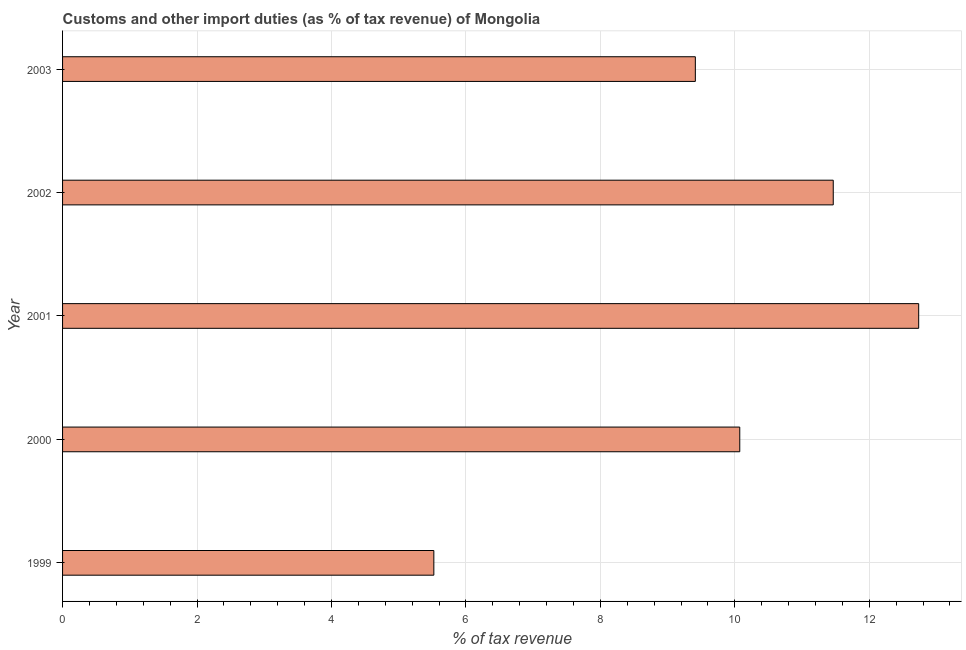Does the graph contain any zero values?
Offer a very short reply. No. Does the graph contain grids?
Your answer should be compact. Yes. What is the title of the graph?
Your answer should be compact. Customs and other import duties (as % of tax revenue) of Mongolia. What is the label or title of the X-axis?
Make the answer very short. % of tax revenue. What is the label or title of the Y-axis?
Your answer should be very brief. Year. What is the customs and other import duties in 2003?
Keep it short and to the point. 9.41. Across all years, what is the maximum customs and other import duties?
Your answer should be very brief. 12.74. Across all years, what is the minimum customs and other import duties?
Offer a very short reply. 5.52. What is the sum of the customs and other import duties?
Offer a terse response. 49.21. What is the difference between the customs and other import duties in 2001 and 2002?
Offer a terse response. 1.27. What is the average customs and other import duties per year?
Your answer should be very brief. 9.84. What is the median customs and other import duties?
Your response must be concise. 10.07. In how many years, is the customs and other import duties greater than 0.8 %?
Keep it short and to the point. 5. What is the ratio of the customs and other import duties in 1999 to that in 2001?
Offer a terse response. 0.43. What is the difference between the highest and the second highest customs and other import duties?
Ensure brevity in your answer.  1.27. What is the difference between the highest and the lowest customs and other import duties?
Keep it short and to the point. 7.21. How many bars are there?
Offer a terse response. 5. Are all the bars in the graph horizontal?
Your answer should be compact. Yes. Are the values on the major ticks of X-axis written in scientific E-notation?
Your answer should be very brief. No. What is the % of tax revenue in 1999?
Offer a terse response. 5.52. What is the % of tax revenue of 2000?
Offer a very short reply. 10.07. What is the % of tax revenue of 2001?
Give a very brief answer. 12.74. What is the % of tax revenue in 2002?
Ensure brevity in your answer.  11.46. What is the % of tax revenue of 2003?
Give a very brief answer. 9.41. What is the difference between the % of tax revenue in 1999 and 2000?
Offer a very short reply. -4.55. What is the difference between the % of tax revenue in 1999 and 2001?
Keep it short and to the point. -7.21. What is the difference between the % of tax revenue in 1999 and 2002?
Offer a very short reply. -5.94. What is the difference between the % of tax revenue in 1999 and 2003?
Provide a succinct answer. -3.89. What is the difference between the % of tax revenue in 2000 and 2001?
Your answer should be very brief. -2.66. What is the difference between the % of tax revenue in 2000 and 2002?
Keep it short and to the point. -1.39. What is the difference between the % of tax revenue in 2000 and 2003?
Keep it short and to the point. 0.66. What is the difference between the % of tax revenue in 2001 and 2002?
Offer a terse response. 1.27. What is the difference between the % of tax revenue in 2001 and 2003?
Make the answer very short. 3.32. What is the difference between the % of tax revenue in 2002 and 2003?
Make the answer very short. 2.05. What is the ratio of the % of tax revenue in 1999 to that in 2000?
Your answer should be very brief. 0.55. What is the ratio of the % of tax revenue in 1999 to that in 2001?
Offer a very short reply. 0.43. What is the ratio of the % of tax revenue in 1999 to that in 2002?
Ensure brevity in your answer.  0.48. What is the ratio of the % of tax revenue in 1999 to that in 2003?
Your answer should be very brief. 0.59. What is the ratio of the % of tax revenue in 2000 to that in 2001?
Your response must be concise. 0.79. What is the ratio of the % of tax revenue in 2000 to that in 2002?
Give a very brief answer. 0.88. What is the ratio of the % of tax revenue in 2000 to that in 2003?
Make the answer very short. 1.07. What is the ratio of the % of tax revenue in 2001 to that in 2002?
Your answer should be compact. 1.11. What is the ratio of the % of tax revenue in 2001 to that in 2003?
Provide a short and direct response. 1.35. What is the ratio of the % of tax revenue in 2002 to that in 2003?
Offer a very short reply. 1.22. 